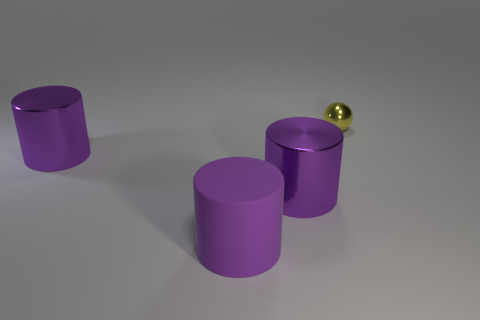Subtract 1 cylinders. How many cylinders are left? 2 Subtract all big purple shiny cylinders. How many cylinders are left? 1 Add 1 purple cylinders. How many objects exist? 5 Subtract all cylinders. How many objects are left? 1 Add 1 yellow balls. How many yellow balls exist? 2 Subtract 0 gray cylinders. How many objects are left? 4 Subtract all red cylinders. Subtract all cyan cubes. How many cylinders are left? 3 Subtract all yellow spheres. Subtract all yellow shiny spheres. How many objects are left? 2 Add 1 big matte cylinders. How many big matte cylinders are left? 2 